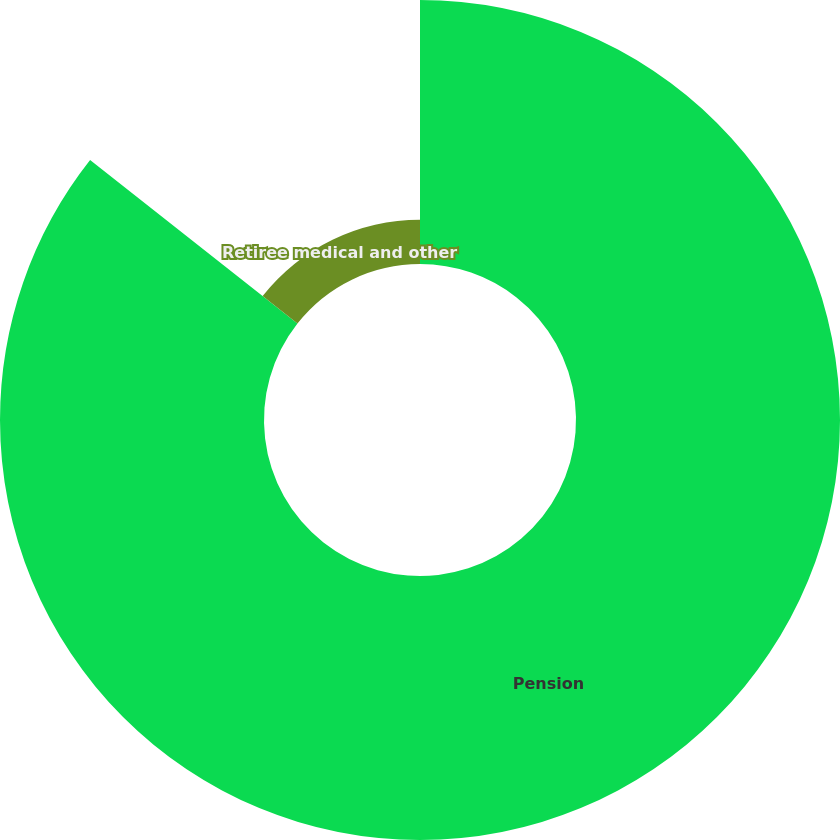<chart> <loc_0><loc_0><loc_500><loc_500><pie_chart><fcel>Pension<fcel>Retiree medical and other<nl><fcel>85.62%<fcel>14.38%<nl></chart> 